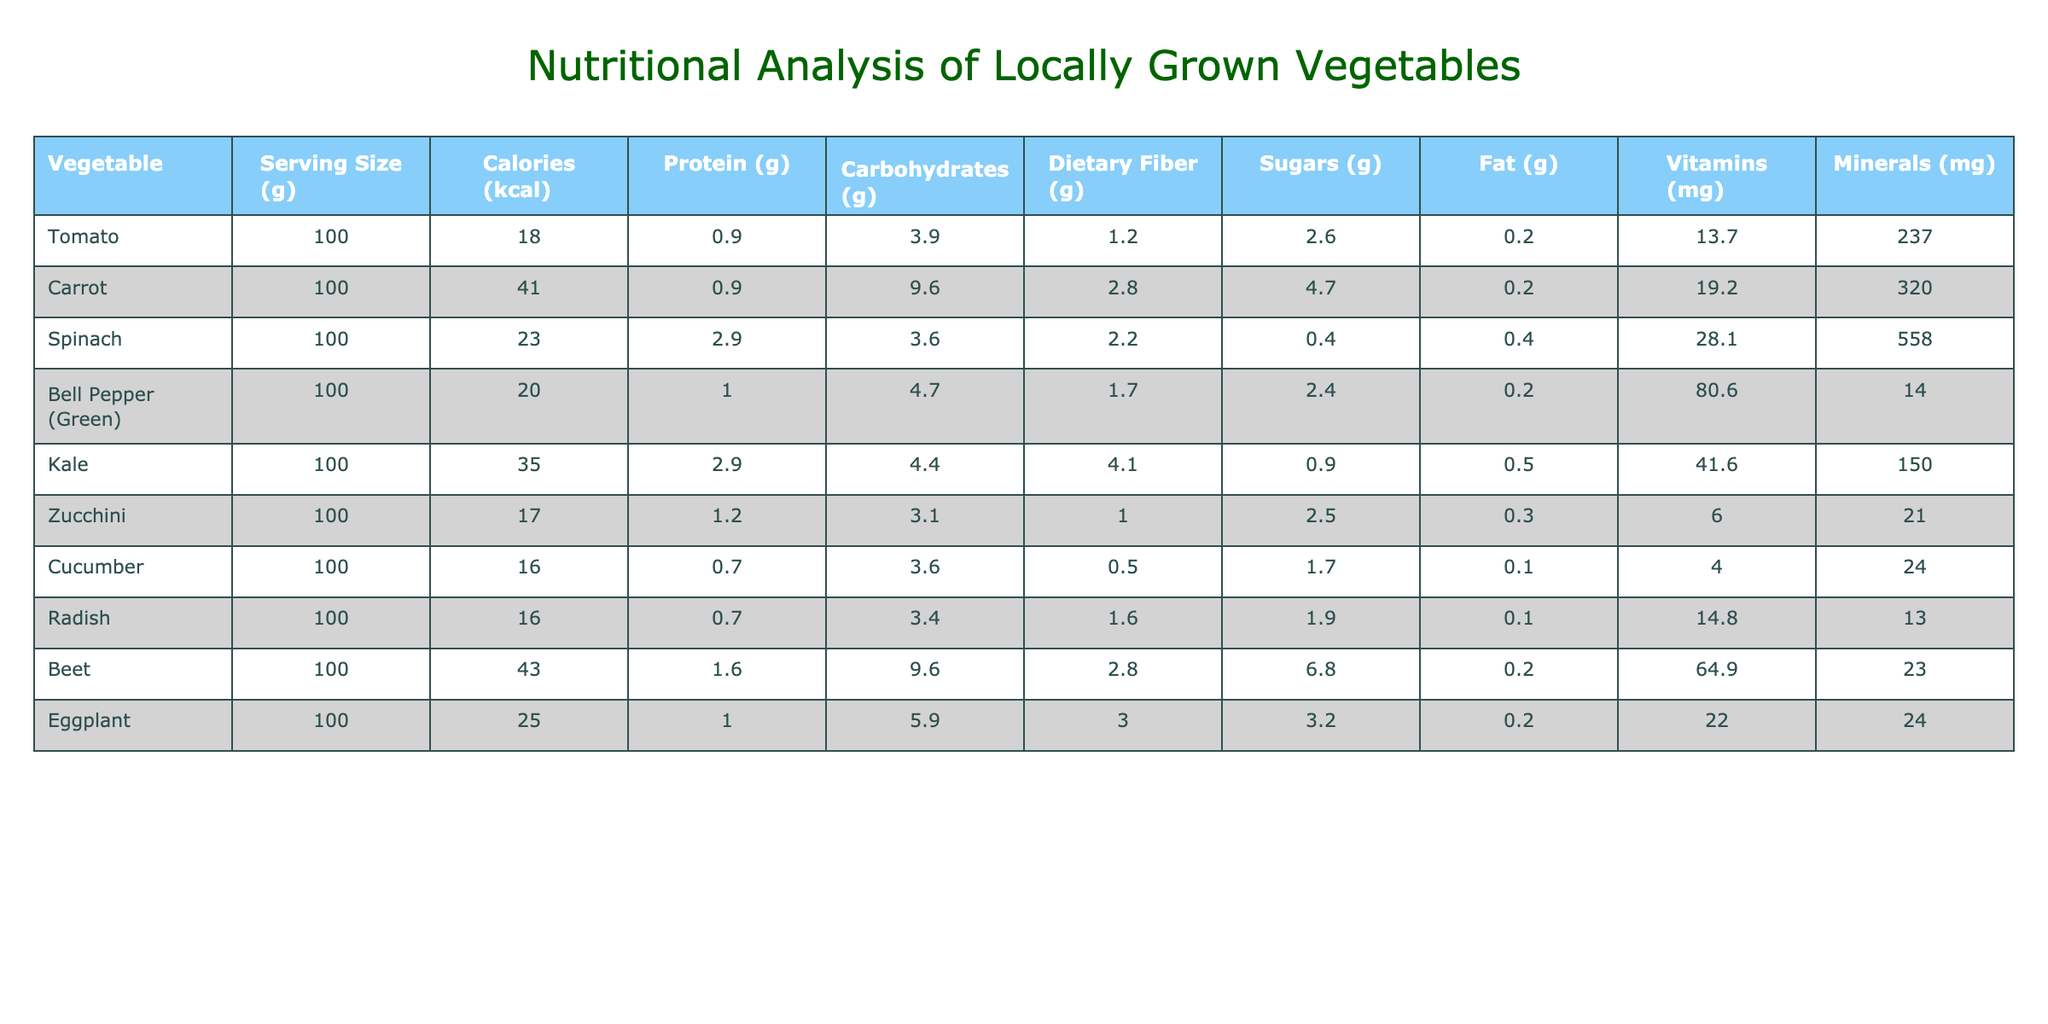What vegetable has the highest amount of calories per 100g? Looking at the "Calories (kcal)" column, the vegetable with the highest value is Beet, which has 43 calories per 100g.
Answer: Beet What is the protein content in Spinach? From the table, Spinach contains 2.9 grams of protein per 100g, as indicated in the "Protein (g)" column.
Answer: 2.9g Are there any vegetables in the table that have a fat content of less than 0.2g per 100g? By checking the "Fat (g)" column, we see that Cucumber and Radish have fat contents of 0.1g, which is less than 0.2g. Therefore, the answer is yes.
Answer: Yes What is the total dietary fiber content of Carrot and Kale combined? The dietary fiber content for Carrot is 2.8g and for Kale is 4.1g. Adding these together gives 2.8 + 4.1 = 6.9g of dietary fiber.
Answer: 6.9g Which vegetable has the highest sugar content per 100g? Observing the "Sugars (g)" column, Beet has the highest sugar content with 6.8g per 100g.
Answer: Beet 